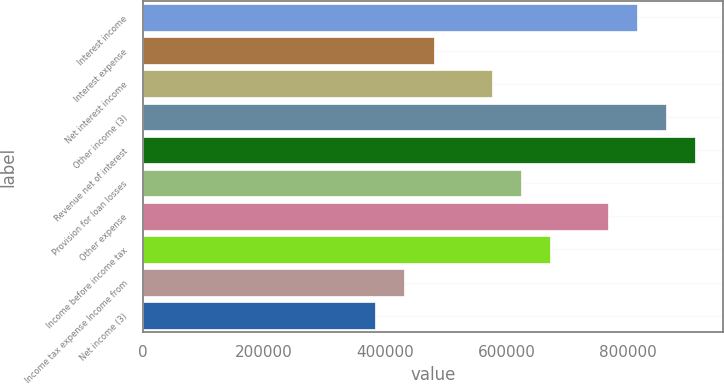Convert chart. <chart><loc_0><loc_0><loc_500><loc_500><bar_chart><fcel>Interest income<fcel>Interest expense<fcel>Net interest income<fcel>Other income (3)<fcel>Revenue net of interest<fcel>Provision for loan losses<fcel>Other expense<fcel>Income before income tax<fcel>Income tax expense Income from<fcel>Net income (3)<nl><fcel>814907<fcel>479357<fcel>575228<fcel>862842<fcel>910778<fcel>623164<fcel>766971<fcel>671100<fcel>431421<fcel>383486<nl></chart> 